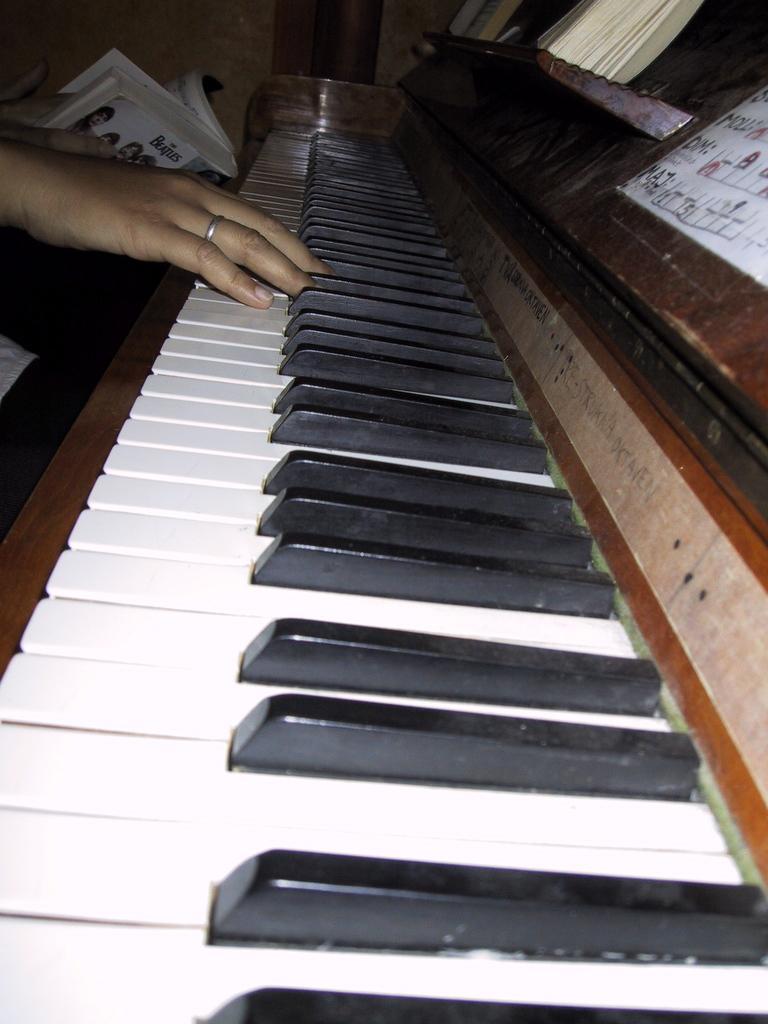How would you summarize this image in a sentence or two? In the image we can see there is a piano and a person is typing on it and even holding a book. 